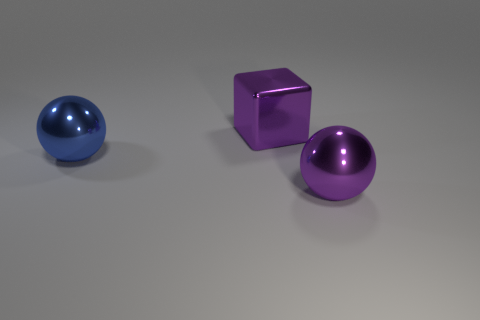Is there a large object in front of the object that is in front of the blue ball?
Provide a succinct answer. No. Is the number of purple cubes that are behind the big metal cube less than the number of purple shiny things that are on the right side of the purple ball?
Give a very brief answer. No. There is a purple object to the left of the large metal thing in front of the large metal object that is to the left of the big shiny block; what size is it?
Keep it short and to the point. Large. There is a purple thing that is behind the blue object; is its size the same as the blue thing?
Provide a short and direct response. Yes. What number of other things are the same material as the big blue ball?
Your response must be concise. 2. Is the number of objects greater than the number of purple blocks?
Make the answer very short. Yes. There is a sphere that is on the left side of the purple shiny thing that is in front of the big blue object that is on the left side of the large metal block; what is its material?
Offer a terse response. Metal. Is there another large block that has the same color as the metal block?
Make the answer very short. No. What is the shape of the purple metallic thing that is the same size as the purple block?
Your answer should be compact. Sphere. Is the number of purple things less than the number of large blue metallic cubes?
Your answer should be compact. No. 